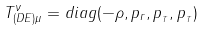<formula> <loc_0><loc_0><loc_500><loc_500>T _ { ( D E ) \mu } ^ { \nu } = d i a g ( - \rho , p _ { r } , p _ { _ { T } } , p _ { _ { T } } )</formula> 